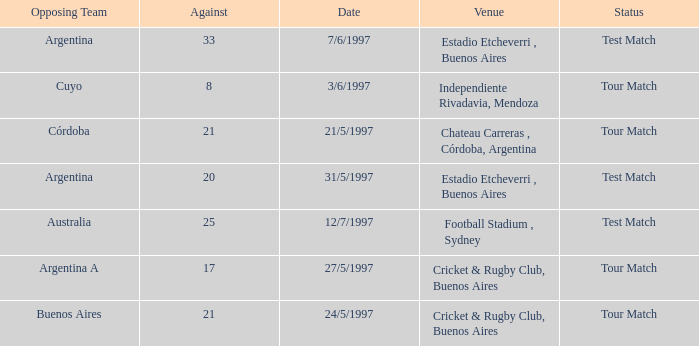Parse the table in full. {'header': ['Opposing Team', 'Against', 'Date', 'Venue', 'Status'], 'rows': [['Argentina', '33', '7/6/1997', 'Estadio Etcheverri , Buenos Aires', 'Test Match'], ['Cuyo', '8', '3/6/1997', 'Independiente Rivadavia, Mendoza', 'Tour Match'], ['Córdoba', '21', '21/5/1997', 'Chateau Carreras , Córdoba, Argentina', 'Tour Match'], ['Argentina', '20', '31/5/1997', 'Estadio Etcheverri , Buenos Aires', 'Test Match'], ['Australia', '25', '12/7/1997', 'Football Stadium , Sydney', 'Test Match'], ['Argentina A', '17', '27/5/1997', 'Cricket & Rugby Club, Buenos Aires', 'Tour Match'], ['Buenos Aires', '21', '24/5/1997', 'Cricket & Rugby Club, Buenos Aires', 'Tour Match']]} Which venue has an against value larger than 21 and had Argentina as an opposing team. Estadio Etcheverri , Buenos Aires. 